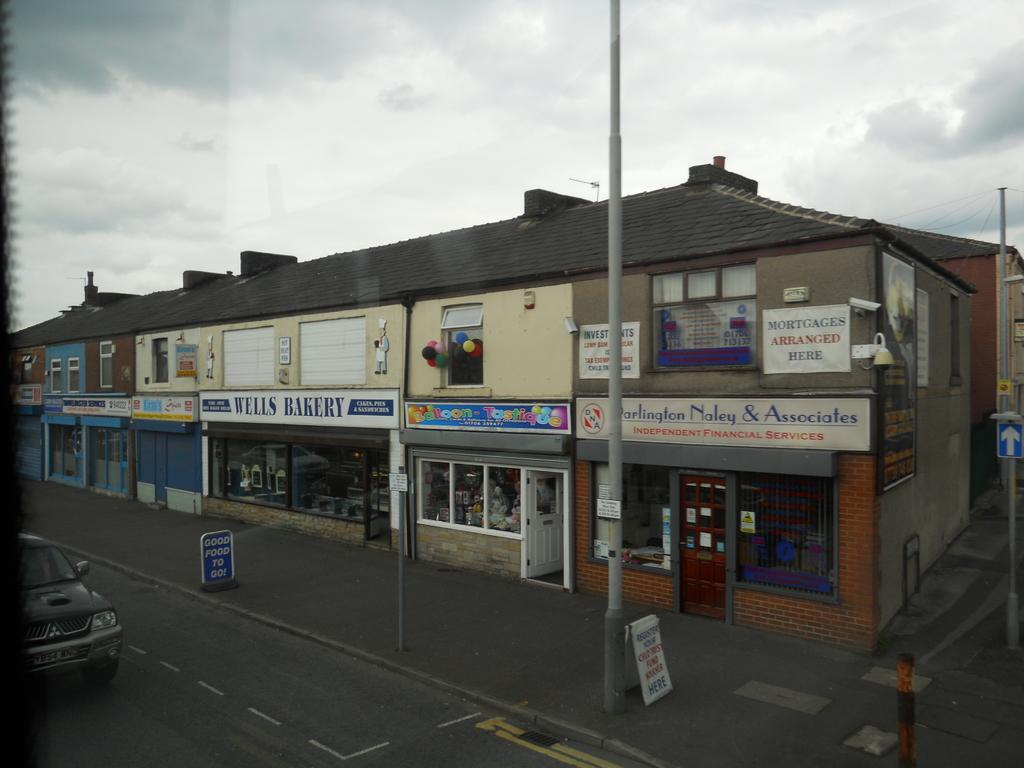Can you describe this image briefly? In this image we can see buildings, boards, poles, doors, and a vehicle on the road. In the background there is sky with clouds. 